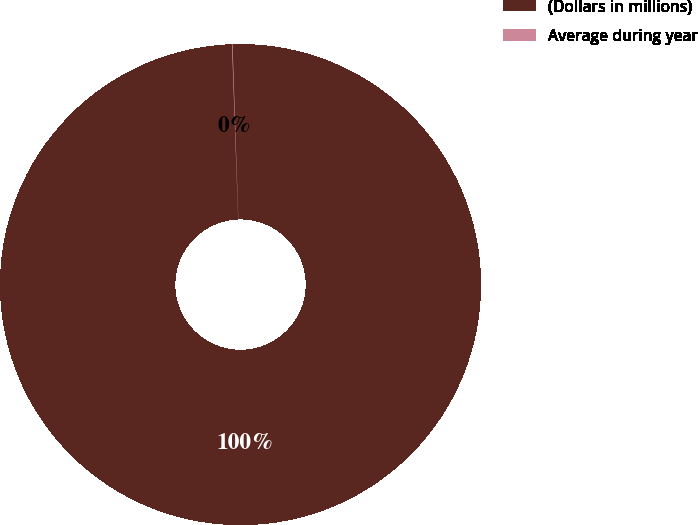Convert chart. <chart><loc_0><loc_0><loc_500><loc_500><pie_chart><fcel>(Dollars in millions)<fcel>Average during year<nl><fcel>99.96%<fcel>0.04%<nl></chart> 